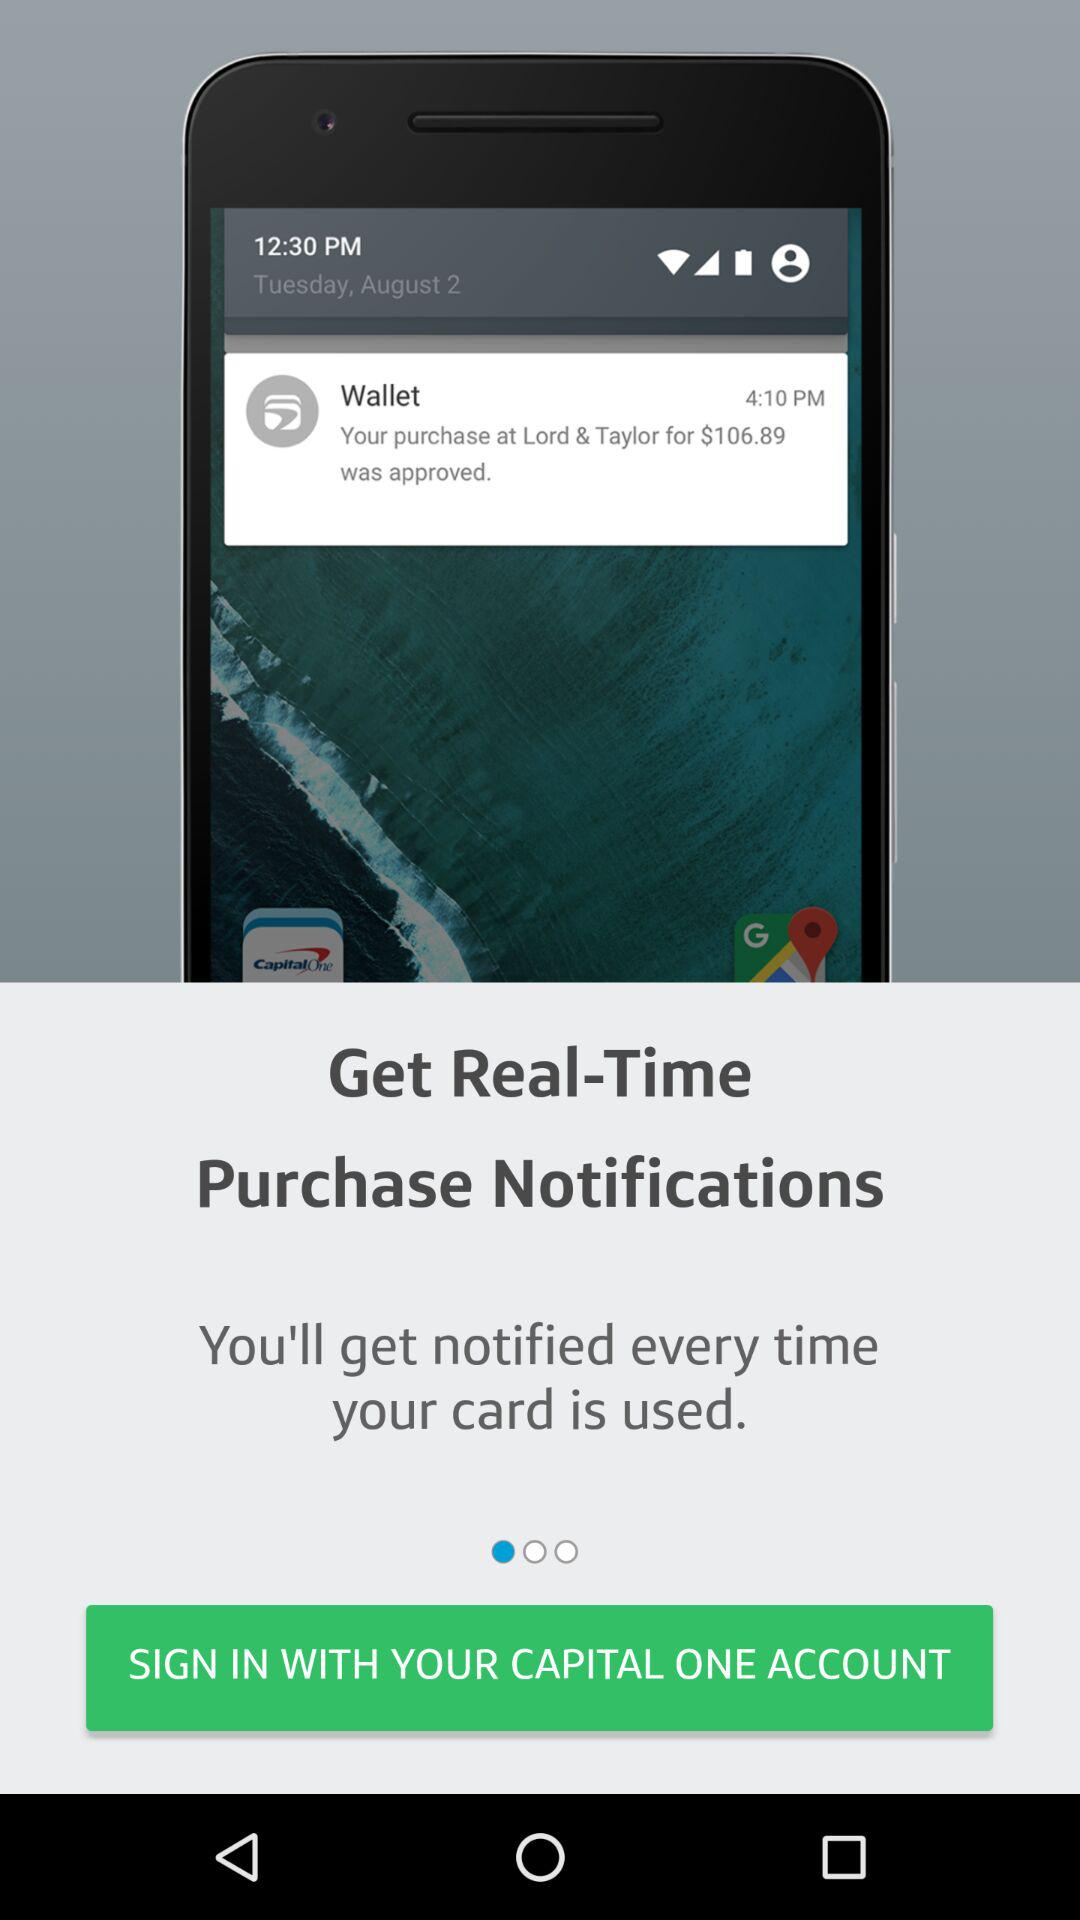What is the given date on the mobile screen? The given date on the mobile screen is Tuesday, August 2. 